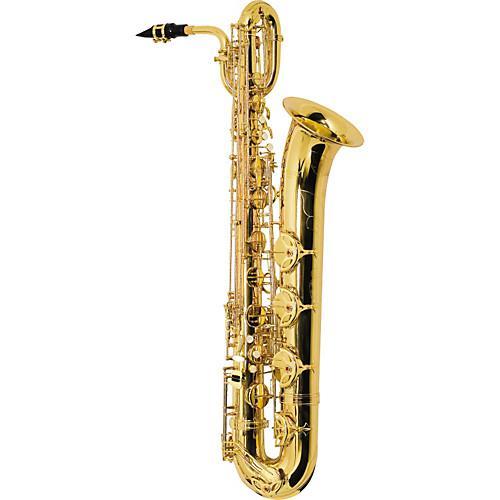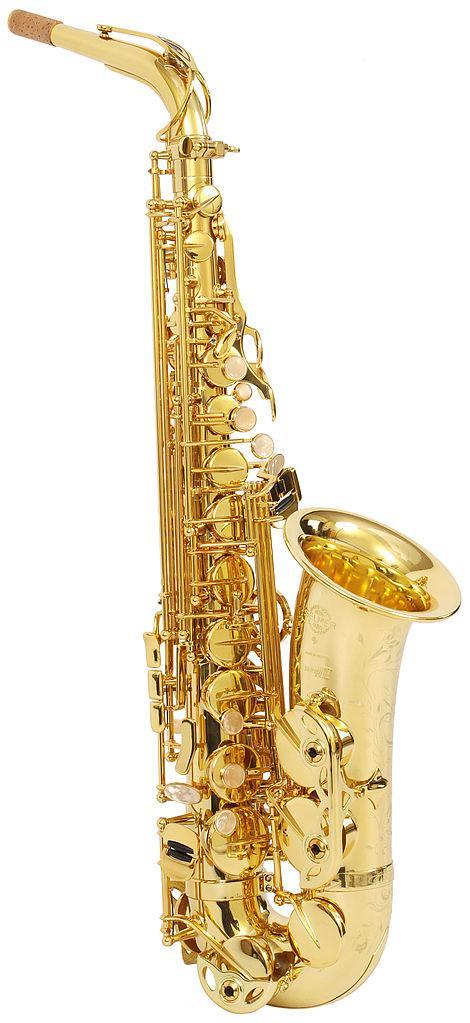The first image is the image on the left, the second image is the image on the right. Analyze the images presented: Is the assertion "There is exactly one black mouthpiece." valid? Answer yes or no. Yes. The first image is the image on the left, the second image is the image on the right. For the images shown, is this caption "Each image shows one upright gold colored saxophone with its bell facing rightward and its mouthpiece facing leftward, and at least one of the saxophones pictured has a loop shape at the top." true? Answer yes or no. Yes. 